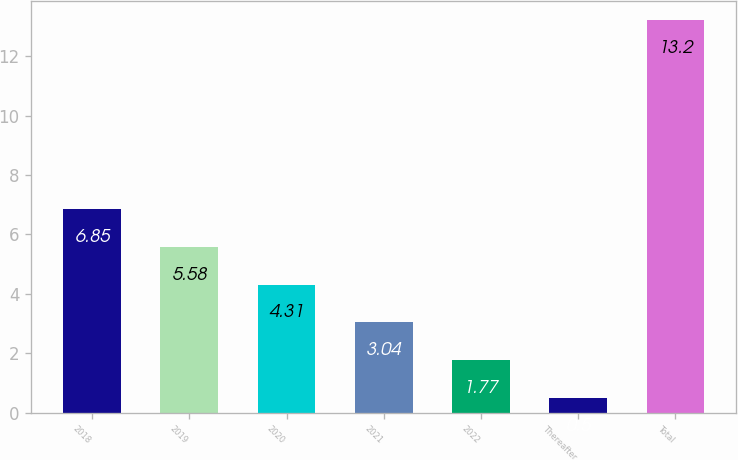Convert chart. <chart><loc_0><loc_0><loc_500><loc_500><bar_chart><fcel>2018<fcel>2019<fcel>2020<fcel>2021<fcel>2022<fcel>Thereafter<fcel>Total<nl><fcel>6.85<fcel>5.58<fcel>4.31<fcel>3.04<fcel>1.77<fcel>0.5<fcel>13.2<nl></chart> 